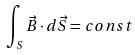Convert formula to latex. <formula><loc_0><loc_0><loc_500><loc_500>\int _ { S } \vec { B } \cdot d \vec { S } = c o n s t</formula> 